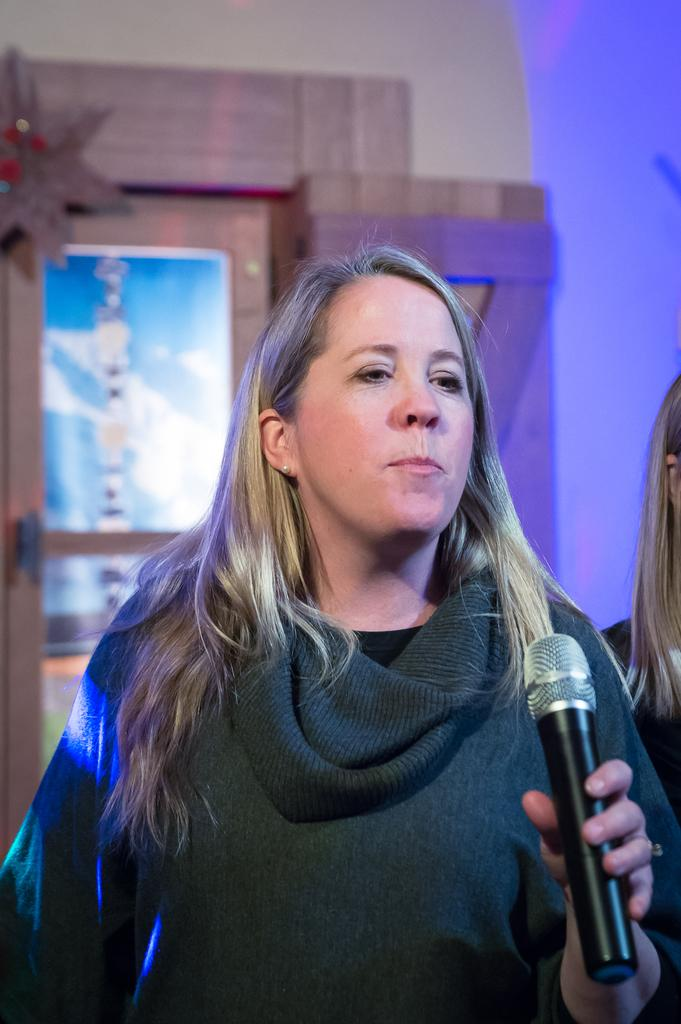What is the main subject of the image? The main subject of the image is a woman. What is the woman doing in the image? The woman is standing in the image. What object is the woman holding in the image? The woman is holding a microphone in the image. Can you see any ants crawling on the woman in the image? There are no ants visible in the image. Is the woman in a prison in the image? There is no indication of a prison or any confinement in the image. 